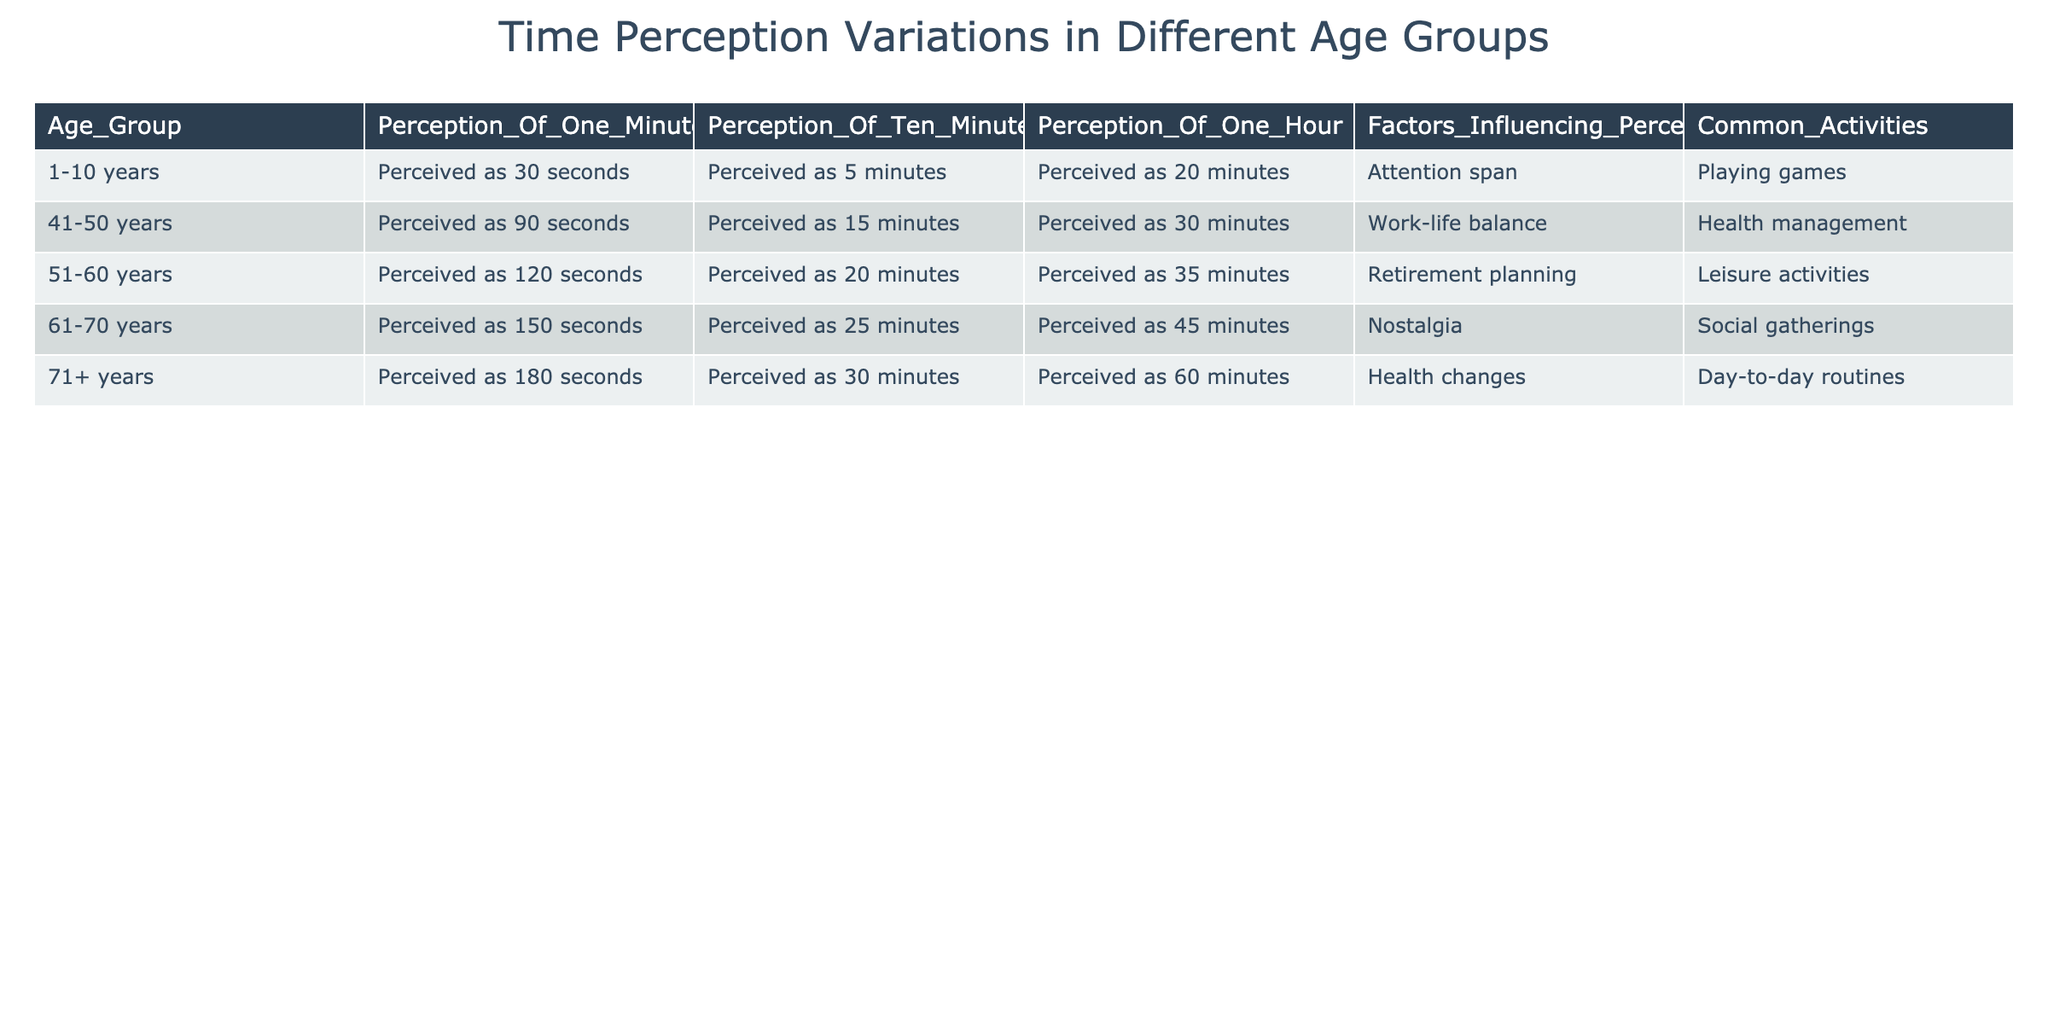What is the perceived length of one minute for the age group 1-10 years? According to the table, the age group 1-10 years perceives one minute as 30 seconds. This is directly stated in the row corresponding to that age group.
Answer: 30 seconds Which age group perceives ten minutes as 15 minutes? The table shows that the age group 41-50 years perceives ten minutes as 15 minutes. This is found by looking at the corresponding row for that age group.
Answer: 41-50 years What is the average perceived time of one hour across all age groups? The perceived times for one hour by each age group are: 20 minutes, 30 minutes, 35 minutes, 45 minutes, and 60 minutes. To calculate the average, sum these values: (20 + 30 + 35 + 45 + 60) = 190. There are 5 age groups, so the average is 190/5 = 38 minutes.
Answer: 38 minutes Is it true that all age groups perceive one hour as 60 minutes? Examining the table, we see that the perceived time for one hour is actually different for each age group. The most accurate perception of one hour is that of the age group 71+, which perceives it as 60 minutes. Therefore, the statement is false for the other groups.
Answer: No Which age group has the highest perceived time for one minute? The table lists the perceived time for one minute as follows: 30 seconds (1-10 years), 90 seconds (41-50 years), 120 seconds (51-60 years), 150 seconds (61-70 years), and 180 seconds (71+ years). The age group 71+ years has the highest perceived time, which is 180 seconds.
Answer: 71+ years What common activity is associated with the age group 61-70 years? According to the table, the common activity for the age group 61-70 years is social gatherings. This information is listed in the Common Activities column specifically for that age group.
Answer: Social gatherings How much longer does the 71+ age group perceive ten minutes compared to the 1-10 age group? For the 71+ age group, ten minutes is perceived as 30 minutes, while for the 1-10 age group, it is perceived as 5 minutes. The difference in perception is 30 minutes - 5 minutes = 25 minutes. Therefore, the 71+ age group perceives ten minutes as 25 minutes longer than the 1-10 age group.
Answer: 25 minutes What factors influence perception for the age group 51-60 years? The table indicates that factors influencing perception for the age group 51-60 years include retirement planning and leisure activities. This information is straightforwardly located in the corresponding row for that age group.
Answer: Retirement planning, leisure activities 